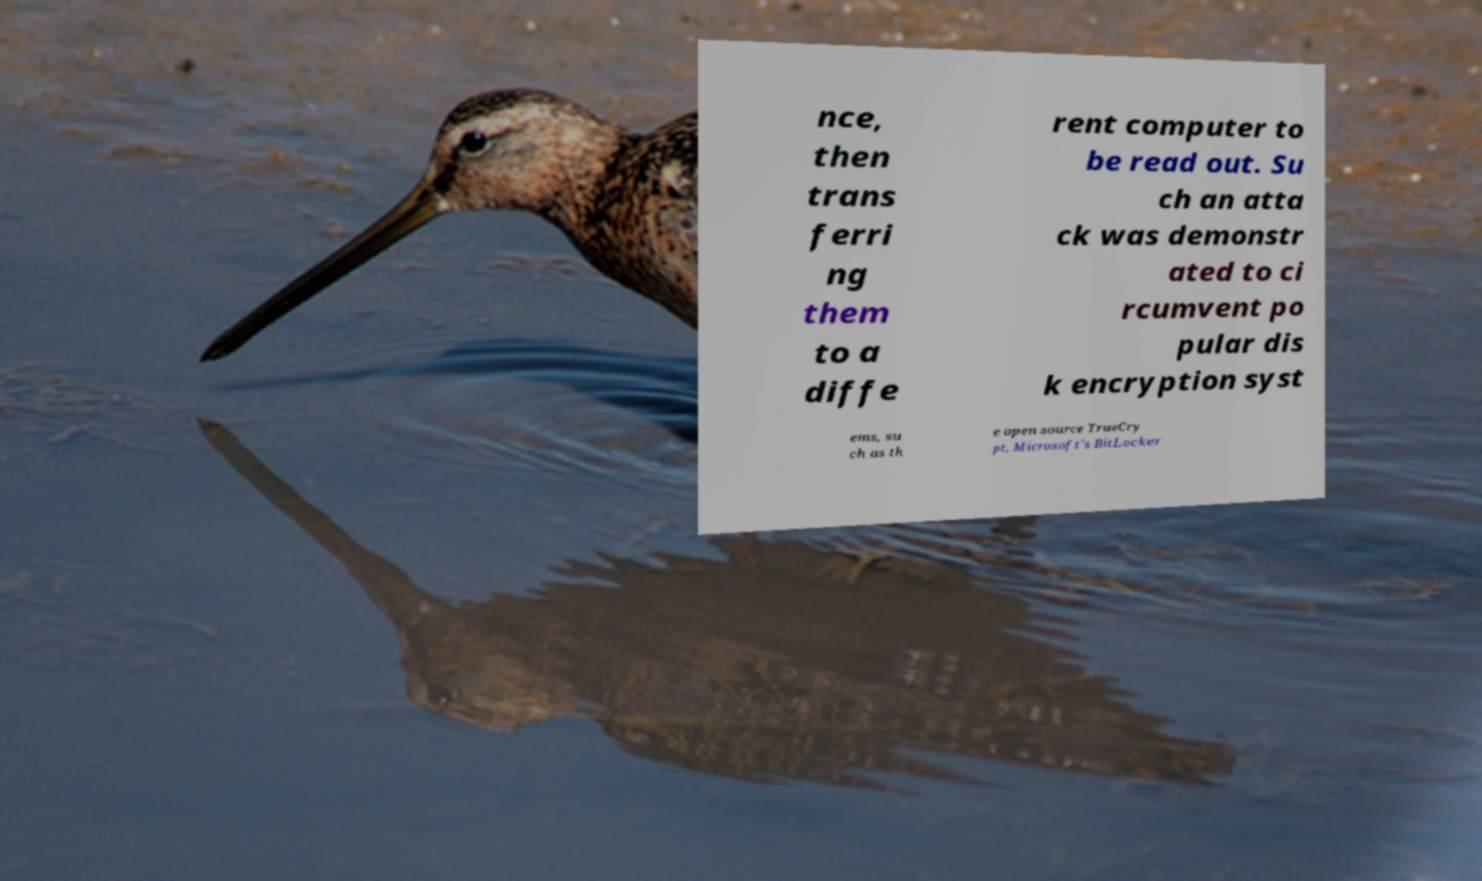Please read and relay the text visible in this image. What does it say? nce, then trans ferri ng them to a diffe rent computer to be read out. Su ch an atta ck was demonstr ated to ci rcumvent po pular dis k encryption syst ems, su ch as th e open source TrueCry pt, Microsoft's BitLocker 